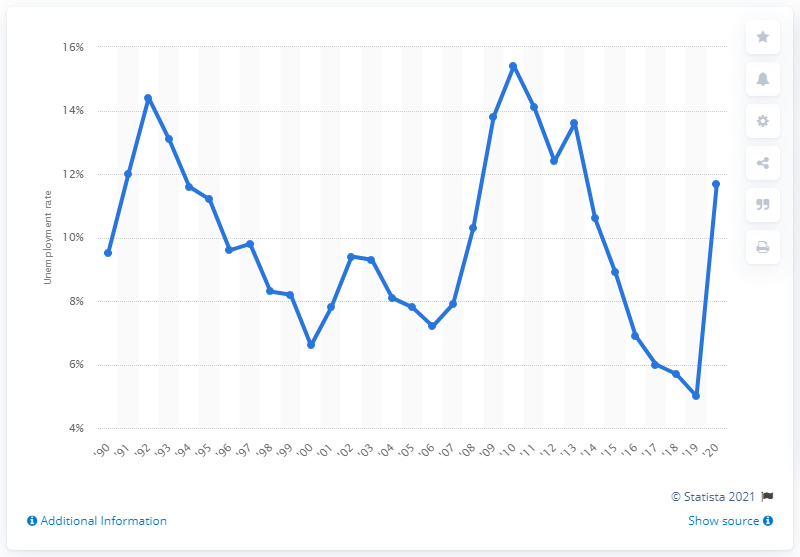List a handful of essential elements in this visual. In 2020, the unemployment rate among Puerto Rican Americans was 11.7%. 